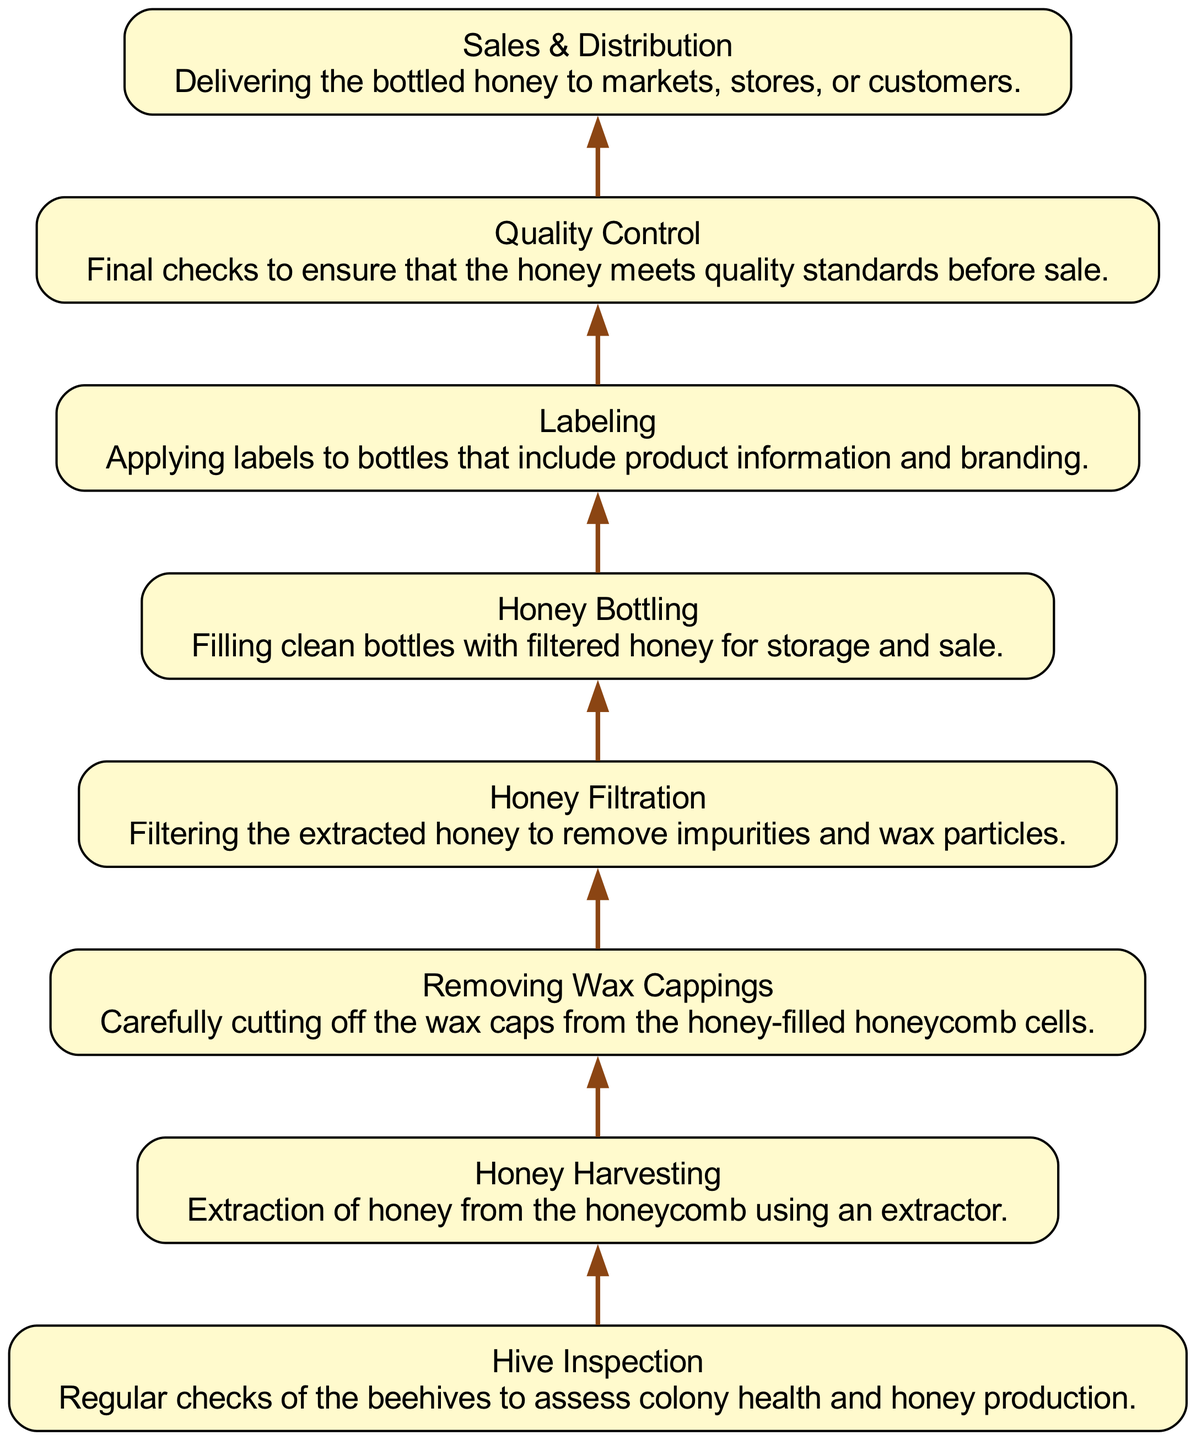What is the first step in the honey production workflow? The first step in the workflow is labeled as "Hive Inspection," where regular checks of the beehives are conducted to assess colony health and honey production.
Answer: Hive Inspection How many steps are involved in this workflow? There are a total of eight steps shown in the diagram, each representing a different part of the honey production process.
Answer: Eight What is the final step in the honey production process? The final step indicated in the workflow is "Sales & Distribution," which involves delivering the bottled honey to markets, stores, or customers.
Answer: Sales & Distribution What is the relationship between "Removing Wax Cappings" and "Honey Filtration"? "Removing Wax Cappings" directly precedes "Honey Filtration" in the workflow, indicating that wax cappings must be removed before the honey can be filtered.
Answer: Directly precedes Which step follows "Honey Harvesting"? After "Honey Harvesting," the next step is "Removing Wax Cappings," indicating that honey extraction is followed by removing the wax caps from honeycomb cells.
Answer: Removing Wax Cappings What two steps are performed before "Honey Bottling"? The two steps performed before "Honey Bottling" are "Honey Filtration" and "Quality Control," showing that honey must be filtered and quality checked before bottling.
Answer: Honey Filtration, Quality Control In what order are the extraction and filtration steps arranged? The order of the extraction and filtration steps is that "Honey Harvesting" occurs first, followed by "Honey Filtration." This shows the sequence of honey being extracted and then filtered.
Answer: Harvesting, Filtration What step includes applying product information to the honey bottles? The step that includes applying product information to the honey bottles is labeled as "Labeling." This is crucial for branding and sales purposes.
Answer: Labeling 